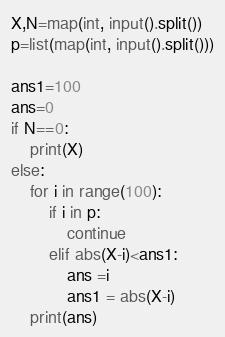<code> <loc_0><loc_0><loc_500><loc_500><_Python_>X,N=map(int, input().split())
p=list(map(int, input().split()))

ans1=100
ans=0
if N==0:
    print(X)
else:
    for i in range(100):
        if i in p:
            continue
        elif abs(X-i)<ans1:
            ans =i
            ans1 = abs(X-i)
    print(ans)</code> 